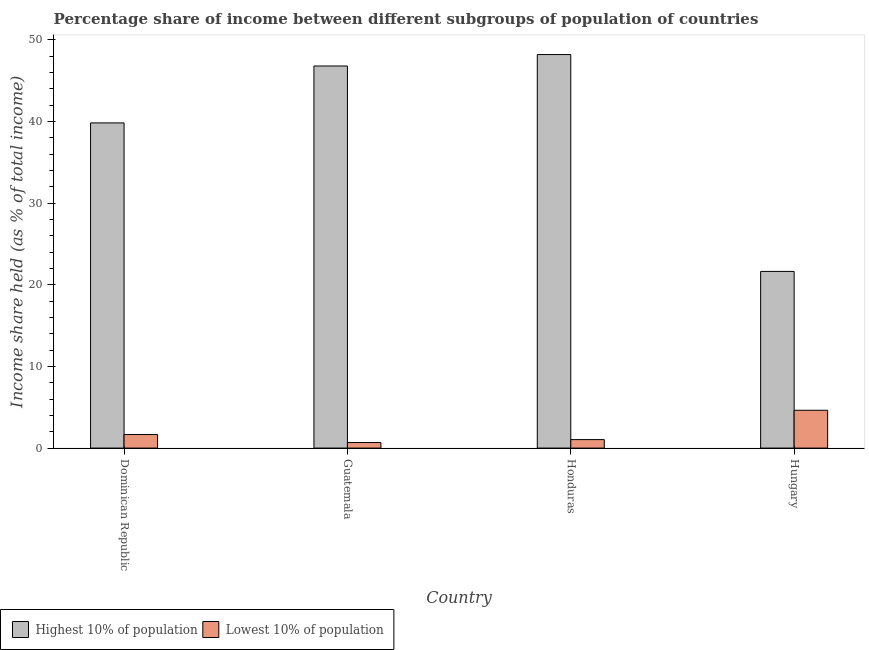Are the number of bars per tick equal to the number of legend labels?
Make the answer very short. Yes. How many bars are there on the 4th tick from the left?
Your answer should be very brief. 2. How many bars are there on the 1st tick from the right?
Offer a very short reply. 2. What is the label of the 1st group of bars from the left?
Make the answer very short. Dominican Republic. Across all countries, what is the maximum income share held by lowest 10% of the population?
Provide a succinct answer. 4.63. Across all countries, what is the minimum income share held by highest 10% of the population?
Your response must be concise. 21.63. In which country was the income share held by lowest 10% of the population maximum?
Give a very brief answer. Hungary. In which country was the income share held by lowest 10% of the population minimum?
Your response must be concise. Guatemala. What is the total income share held by highest 10% of the population in the graph?
Ensure brevity in your answer.  156.4. What is the difference between the income share held by lowest 10% of the population in Honduras and that in Hungary?
Your answer should be compact. -3.59. What is the difference between the income share held by lowest 10% of the population in Hungary and the income share held by highest 10% of the population in Honduras?
Your answer should be very brief. -43.55. What is the average income share held by lowest 10% of the population per country?
Offer a very short reply. 2. What is the difference between the income share held by highest 10% of the population and income share held by lowest 10% of the population in Guatemala?
Keep it short and to the point. 46.1. What is the ratio of the income share held by lowest 10% of the population in Dominican Republic to that in Honduras?
Your answer should be very brief. 1.6. Is the income share held by highest 10% of the population in Honduras less than that in Hungary?
Your answer should be compact. No. What is the difference between the highest and the second highest income share held by lowest 10% of the population?
Offer a very short reply. 2.97. What is the difference between the highest and the lowest income share held by lowest 10% of the population?
Provide a succinct answer. 3.95. In how many countries, is the income share held by lowest 10% of the population greater than the average income share held by lowest 10% of the population taken over all countries?
Provide a short and direct response. 1. What does the 2nd bar from the left in Guatemala represents?
Offer a very short reply. Lowest 10% of population. What does the 1st bar from the right in Dominican Republic represents?
Offer a very short reply. Lowest 10% of population. How many bars are there?
Offer a terse response. 8. Are all the bars in the graph horizontal?
Ensure brevity in your answer.  No. Does the graph contain grids?
Offer a very short reply. No. Where does the legend appear in the graph?
Your response must be concise. Bottom left. How are the legend labels stacked?
Give a very brief answer. Horizontal. What is the title of the graph?
Make the answer very short. Percentage share of income between different subgroups of population of countries. What is the label or title of the Y-axis?
Offer a very short reply. Income share held (as % of total income). What is the Income share held (as % of total income) in Highest 10% of population in Dominican Republic?
Make the answer very short. 39.81. What is the Income share held (as % of total income) of Lowest 10% of population in Dominican Republic?
Provide a short and direct response. 1.66. What is the Income share held (as % of total income) of Highest 10% of population in Guatemala?
Ensure brevity in your answer.  46.78. What is the Income share held (as % of total income) of Lowest 10% of population in Guatemala?
Provide a short and direct response. 0.68. What is the Income share held (as % of total income) of Highest 10% of population in Honduras?
Your response must be concise. 48.18. What is the Income share held (as % of total income) in Highest 10% of population in Hungary?
Your response must be concise. 21.63. What is the Income share held (as % of total income) of Lowest 10% of population in Hungary?
Your answer should be very brief. 4.63. Across all countries, what is the maximum Income share held (as % of total income) in Highest 10% of population?
Keep it short and to the point. 48.18. Across all countries, what is the maximum Income share held (as % of total income) of Lowest 10% of population?
Provide a short and direct response. 4.63. Across all countries, what is the minimum Income share held (as % of total income) in Highest 10% of population?
Give a very brief answer. 21.63. Across all countries, what is the minimum Income share held (as % of total income) of Lowest 10% of population?
Give a very brief answer. 0.68. What is the total Income share held (as % of total income) in Highest 10% of population in the graph?
Offer a terse response. 156.4. What is the total Income share held (as % of total income) of Lowest 10% of population in the graph?
Give a very brief answer. 8.01. What is the difference between the Income share held (as % of total income) of Highest 10% of population in Dominican Republic and that in Guatemala?
Make the answer very short. -6.97. What is the difference between the Income share held (as % of total income) of Highest 10% of population in Dominican Republic and that in Honduras?
Ensure brevity in your answer.  -8.37. What is the difference between the Income share held (as % of total income) in Lowest 10% of population in Dominican Republic and that in Honduras?
Offer a very short reply. 0.62. What is the difference between the Income share held (as % of total income) in Highest 10% of population in Dominican Republic and that in Hungary?
Your response must be concise. 18.18. What is the difference between the Income share held (as % of total income) of Lowest 10% of population in Dominican Republic and that in Hungary?
Your response must be concise. -2.97. What is the difference between the Income share held (as % of total income) in Highest 10% of population in Guatemala and that in Honduras?
Provide a succinct answer. -1.4. What is the difference between the Income share held (as % of total income) of Lowest 10% of population in Guatemala and that in Honduras?
Make the answer very short. -0.36. What is the difference between the Income share held (as % of total income) in Highest 10% of population in Guatemala and that in Hungary?
Give a very brief answer. 25.15. What is the difference between the Income share held (as % of total income) of Lowest 10% of population in Guatemala and that in Hungary?
Keep it short and to the point. -3.95. What is the difference between the Income share held (as % of total income) of Highest 10% of population in Honduras and that in Hungary?
Provide a short and direct response. 26.55. What is the difference between the Income share held (as % of total income) of Lowest 10% of population in Honduras and that in Hungary?
Your answer should be compact. -3.59. What is the difference between the Income share held (as % of total income) of Highest 10% of population in Dominican Republic and the Income share held (as % of total income) of Lowest 10% of population in Guatemala?
Keep it short and to the point. 39.13. What is the difference between the Income share held (as % of total income) of Highest 10% of population in Dominican Republic and the Income share held (as % of total income) of Lowest 10% of population in Honduras?
Keep it short and to the point. 38.77. What is the difference between the Income share held (as % of total income) in Highest 10% of population in Dominican Republic and the Income share held (as % of total income) in Lowest 10% of population in Hungary?
Your answer should be very brief. 35.18. What is the difference between the Income share held (as % of total income) in Highest 10% of population in Guatemala and the Income share held (as % of total income) in Lowest 10% of population in Honduras?
Keep it short and to the point. 45.74. What is the difference between the Income share held (as % of total income) in Highest 10% of population in Guatemala and the Income share held (as % of total income) in Lowest 10% of population in Hungary?
Provide a short and direct response. 42.15. What is the difference between the Income share held (as % of total income) in Highest 10% of population in Honduras and the Income share held (as % of total income) in Lowest 10% of population in Hungary?
Provide a succinct answer. 43.55. What is the average Income share held (as % of total income) of Highest 10% of population per country?
Make the answer very short. 39.1. What is the average Income share held (as % of total income) of Lowest 10% of population per country?
Keep it short and to the point. 2. What is the difference between the Income share held (as % of total income) in Highest 10% of population and Income share held (as % of total income) in Lowest 10% of population in Dominican Republic?
Ensure brevity in your answer.  38.15. What is the difference between the Income share held (as % of total income) in Highest 10% of population and Income share held (as % of total income) in Lowest 10% of population in Guatemala?
Your answer should be compact. 46.1. What is the difference between the Income share held (as % of total income) of Highest 10% of population and Income share held (as % of total income) of Lowest 10% of population in Honduras?
Give a very brief answer. 47.14. What is the ratio of the Income share held (as % of total income) of Highest 10% of population in Dominican Republic to that in Guatemala?
Offer a terse response. 0.85. What is the ratio of the Income share held (as % of total income) in Lowest 10% of population in Dominican Republic to that in Guatemala?
Keep it short and to the point. 2.44. What is the ratio of the Income share held (as % of total income) of Highest 10% of population in Dominican Republic to that in Honduras?
Keep it short and to the point. 0.83. What is the ratio of the Income share held (as % of total income) in Lowest 10% of population in Dominican Republic to that in Honduras?
Ensure brevity in your answer.  1.6. What is the ratio of the Income share held (as % of total income) of Highest 10% of population in Dominican Republic to that in Hungary?
Ensure brevity in your answer.  1.84. What is the ratio of the Income share held (as % of total income) of Lowest 10% of population in Dominican Republic to that in Hungary?
Provide a succinct answer. 0.36. What is the ratio of the Income share held (as % of total income) of Highest 10% of population in Guatemala to that in Honduras?
Ensure brevity in your answer.  0.97. What is the ratio of the Income share held (as % of total income) of Lowest 10% of population in Guatemala to that in Honduras?
Your response must be concise. 0.65. What is the ratio of the Income share held (as % of total income) in Highest 10% of population in Guatemala to that in Hungary?
Your response must be concise. 2.16. What is the ratio of the Income share held (as % of total income) in Lowest 10% of population in Guatemala to that in Hungary?
Your response must be concise. 0.15. What is the ratio of the Income share held (as % of total income) in Highest 10% of population in Honduras to that in Hungary?
Keep it short and to the point. 2.23. What is the ratio of the Income share held (as % of total income) of Lowest 10% of population in Honduras to that in Hungary?
Your answer should be very brief. 0.22. What is the difference between the highest and the second highest Income share held (as % of total income) of Lowest 10% of population?
Offer a terse response. 2.97. What is the difference between the highest and the lowest Income share held (as % of total income) in Highest 10% of population?
Make the answer very short. 26.55. What is the difference between the highest and the lowest Income share held (as % of total income) in Lowest 10% of population?
Keep it short and to the point. 3.95. 